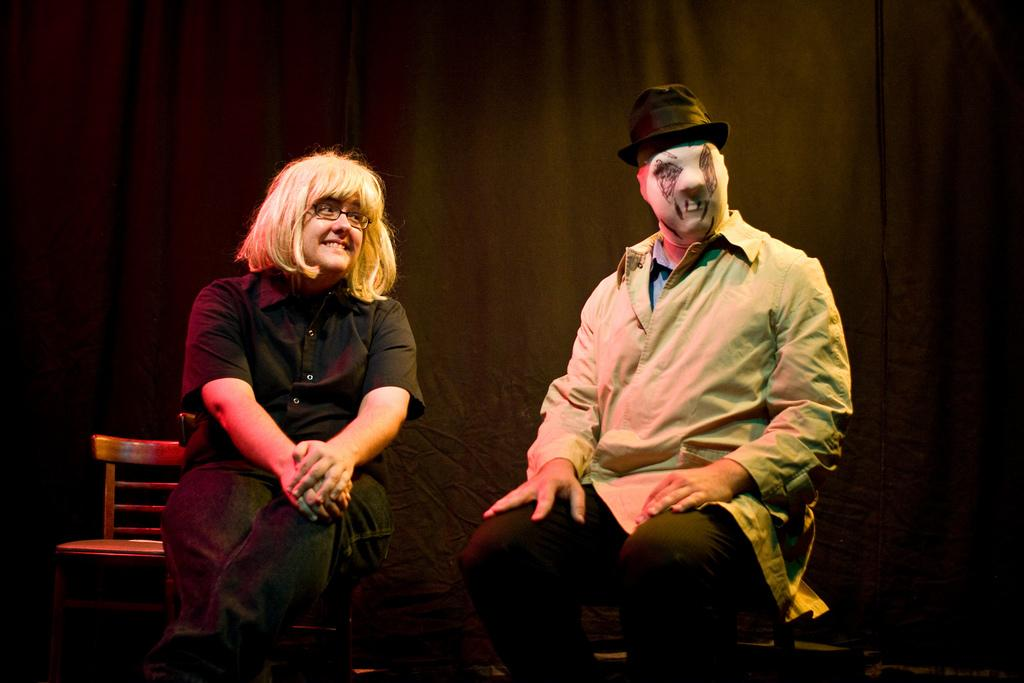How many people are sitting in the image? There are two persons sitting on chairs in the image. Can you describe the appearance of one of the persons? One of the persons is wearing a mask in the image. What can be seen in the background of the image? There are curtains and a chair in the background of the image. What type of rhythm does the cat in the image have? There is no cat present in the image, so it is not possible to determine its rhythm. 